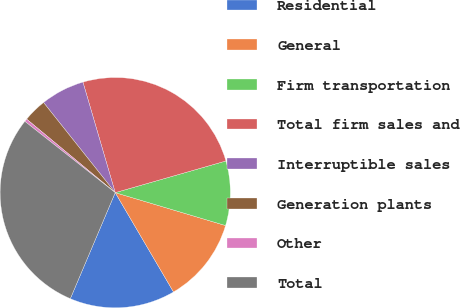<chart> <loc_0><loc_0><loc_500><loc_500><pie_chart><fcel>Residential<fcel>General<fcel>Firm transportation<fcel>Total firm sales and<fcel>Interruptible sales<fcel>Generation plants<fcel>Other<fcel>Total<nl><fcel>14.82%<fcel>11.94%<fcel>9.05%<fcel>25.09%<fcel>6.17%<fcel>3.28%<fcel>0.4%<fcel>29.25%<nl></chart> 